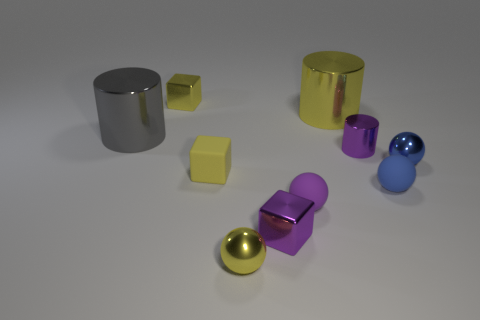Can you describe the texture seen on the surfaces within this image? Within the image, the surfaces of the objects display a variety of textures. The metallic objects have highly reflective surfaces, indicating a smooth texture, while the matte objects, although still smooth, reflect less light and thus have a less glossy appearance. 